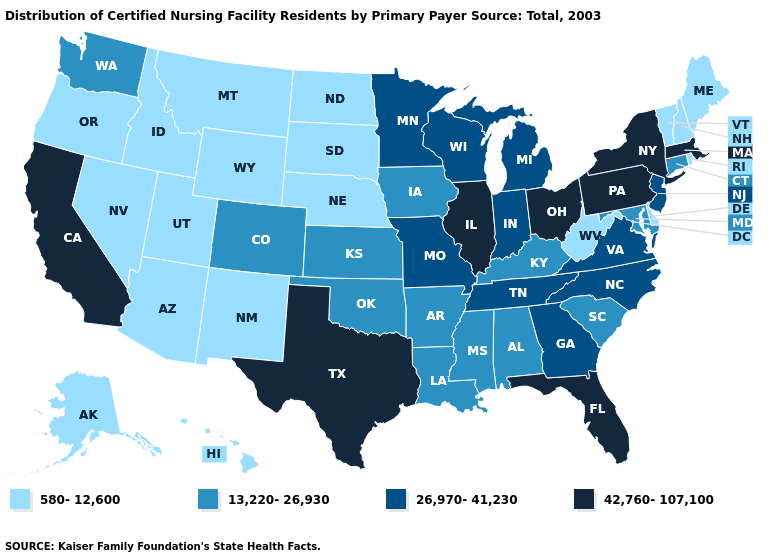Does California have the highest value in the West?
Answer briefly. Yes. Name the states that have a value in the range 26,970-41,230?
Write a very short answer. Georgia, Indiana, Michigan, Minnesota, Missouri, New Jersey, North Carolina, Tennessee, Virginia, Wisconsin. What is the lowest value in the USA?
Be succinct. 580-12,600. What is the value of Kansas?
Give a very brief answer. 13,220-26,930. What is the value of California?
Concise answer only. 42,760-107,100. Among the states that border Rhode Island , does Connecticut have the lowest value?
Concise answer only. Yes. Name the states that have a value in the range 580-12,600?
Quick response, please. Alaska, Arizona, Delaware, Hawaii, Idaho, Maine, Montana, Nebraska, Nevada, New Hampshire, New Mexico, North Dakota, Oregon, Rhode Island, South Dakota, Utah, Vermont, West Virginia, Wyoming. Name the states that have a value in the range 13,220-26,930?
Concise answer only. Alabama, Arkansas, Colorado, Connecticut, Iowa, Kansas, Kentucky, Louisiana, Maryland, Mississippi, Oklahoma, South Carolina, Washington. Among the states that border Montana , which have the lowest value?
Give a very brief answer. Idaho, North Dakota, South Dakota, Wyoming. Among the states that border Washington , which have the lowest value?
Short answer required. Idaho, Oregon. What is the value of New Hampshire?
Write a very short answer. 580-12,600. Which states have the lowest value in the MidWest?
Concise answer only. Nebraska, North Dakota, South Dakota. What is the lowest value in the USA?
Short answer required. 580-12,600. What is the value of Ohio?
Concise answer only. 42,760-107,100. Does Alaska have the lowest value in the West?
Short answer required. Yes. 